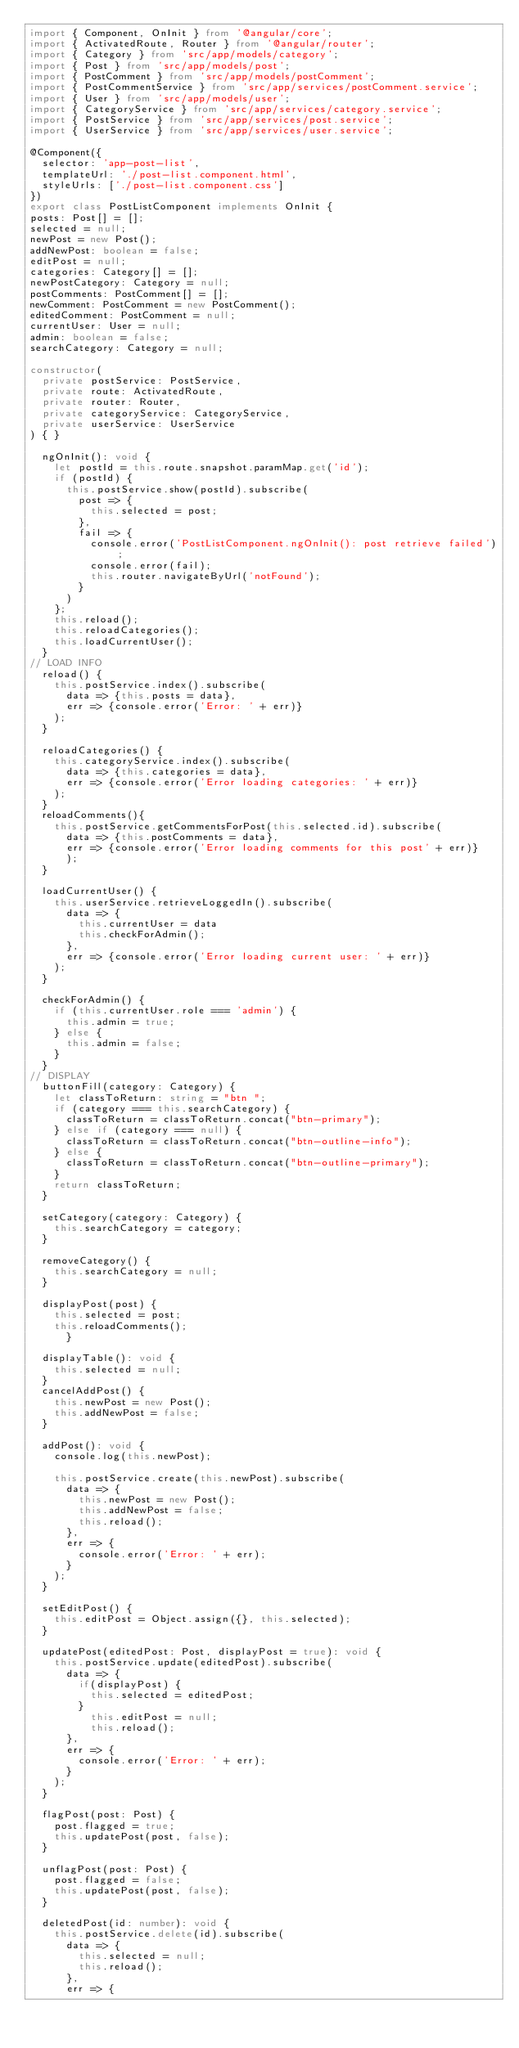Convert code to text. <code><loc_0><loc_0><loc_500><loc_500><_TypeScript_>import { Component, OnInit } from '@angular/core';
import { ActivatedRoute, Router } from '@angular/router';
import { Category } from 'src/app/models/category';
import { Post } from 'src/app/models/post';
import { PostComment } from 'src/app/models/postComment';
import { PostCommentService } from 'src/app/services/postComment.service';
import { User } from 'src/app/models/user';
import { CategoryService } from 'src/app/services/category.service';
import { PostService } from 'src/app/services/post.service';
import { UserService } from 'src/app/services/user.service';

@Component({
  selector: 'app-post-list',
  templateUrl: './post-list.component.html',
  styleUrls: ['./post-list.component.css']
})
export class PostListComponent implements OnInit {
posts: Post[] = [];
selected = null;
newPost = new Post();
addNewPost: boolean = false;
editPost = null;
categories: Category[] = [];
newPostCategory: Category = null;
postComments: PostComment[] = [];
newComment: PostComment = new PostComment();
editedComment: PostComment = null;
currentUser: User = null;
admin: boolean = false;
searchCategory: Category = null;

constructor(
  private postService: PostService,
  private route: ActivatedRoute,
  private router: Router,
  private categoryService: CategoryService,
  private userService: UserService
) { }

  ngOnInit(): void {
    let postId = this.route.snapshot.paramMap.get('id');
    if (postId) {
      this.postService.show(postId).subscribe(
        post => {
          this.selected = post;
        },
        fail => {
          console.error('PostListComponent.ngOnInit(): post retrieve failed');
          console.error(fail);
          this.router.navigateByUrl('notFound');
        }
      )
    };
    this.reload();
    this.reloadCategories();
    this.loadCurrentUser();
  }
// LOAD INFO
  reload() {
    this.postService.index().subscribe(
      data => {this.posts = data},
      err => {console.error('Error: ' + err)}
    );
  }

  reloadCategories() {
    this.categoryService.index().subscribe(
      data => {this.categories = data},
      err => {console.error('Error loading categories: ' + err)}
    );
  }
  reloadComments(){
    this.postService.getCommentsForPost(this.selected.id).subscribe(
      data => {this.postComments = data},
      err => {console.error('Error loading comments for this post' + err)}
      );
  }

  loadCurrentUser() {
    this.userService.retrieveLoggedIn().subscribe(
      data => {
        this.currentUser = data
        this.checkForAdmin();
      },
      err => {console.error('Error loading current user: ' + err)}
    );
  }

  checkForAdmin() {
    if (this.currentUser.role === 'admin') {
      this.admin = true;
    } else {
      this.admin = false;
    }
  }
// DISPLAY
  buttonFill(category: Category) {
    let classToReturn: string = "btn ";
    if (category === this.searchCategory) {
      classToReturn = classToReturn.concat("btn-primary");
    } else if (category === null) {
      classToReturn = classToReturn.concat("btn-outline-info");
    } else {
      classToReturn = classToReturn.concat("btn-outline-primary");
    }
    return classToReturn;
  }

  setCategory(category: Category) {
    this.searchCategory = category;
  }

  removeCategory() {
    this.searchCategory = null;
  }

  displayPost(post) {
    this.selected = post;
    this.reloadComments();
      }

  displayTable(): void {
    this.selected = null;
  }
  cancelAddPost() {
    this.newPost = new Post();
    this.addNewPost = false;
  }

  addPost(): void {
    console.log(this.newPost);

    this.postService.create(this.newPost).subscribe(
      data => {
        this.newPost = new Post();
        this.addNewPost = false;
        this.reload();
      },
      err => {
        console.error('Error: ' + err);
      }
    );
  }

  setEditPost() {
    this.editPost = Object.assign({}, this.selected);
  }

  updatePost(editedPost: Post, displayPost = true): void {
    this.postService.update(editedPost).subscribe(
      data => {
        if(displayPost) {
          this.selected = editedPost;
        }
          this.editPost = null;
          this.reload();
      },
      err => {
        console.error('Error: ' + err);
      }
    );
  }

  flagPost(post: Post) {
    post.flagged = true;
    this.updatePost(post, false);
  }

  unflagPost(post: Post) {
    post.flagged = false;
    this.updatePost(post, false);
  }

  deletedPost(id: number): void {
    this.postService.delete(id).subscribe(
      data => {
        this.selected = null;
        this.reload();
      },
      err => {</code> 